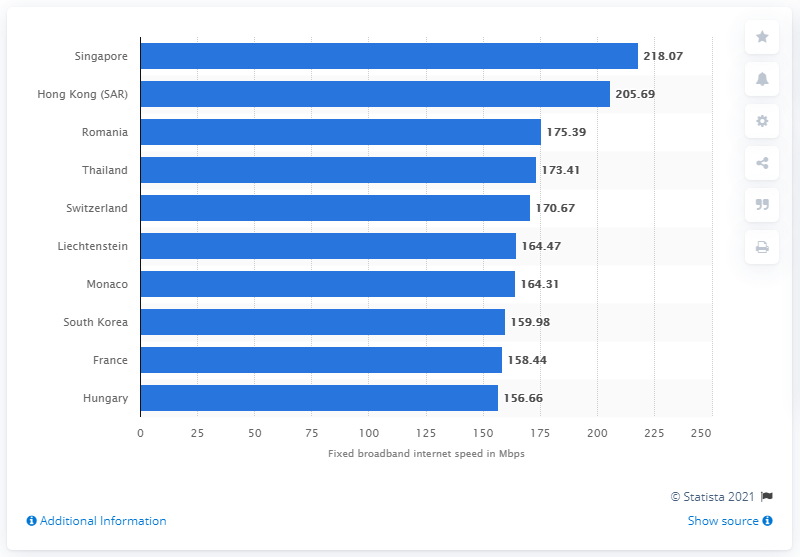Identify some key points in this picture. Singapore had the highest average fixed broadband internet speed in Mbps among all countries in the world. 